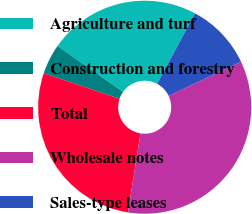Convert chart. <chart><loc_0><loc_0><loc_500><loc_500><pie_chart><fcel>Agriculture and turf<fcel>Construction and forestry<fcel>Total<fcel>Wholesale notes<fcel>Sales-type leases<nl><fcel>23.09%<fcel>4.57%<fcel>27.66%<fcel>34.55%<fcel>10.14%<nl></chart> 